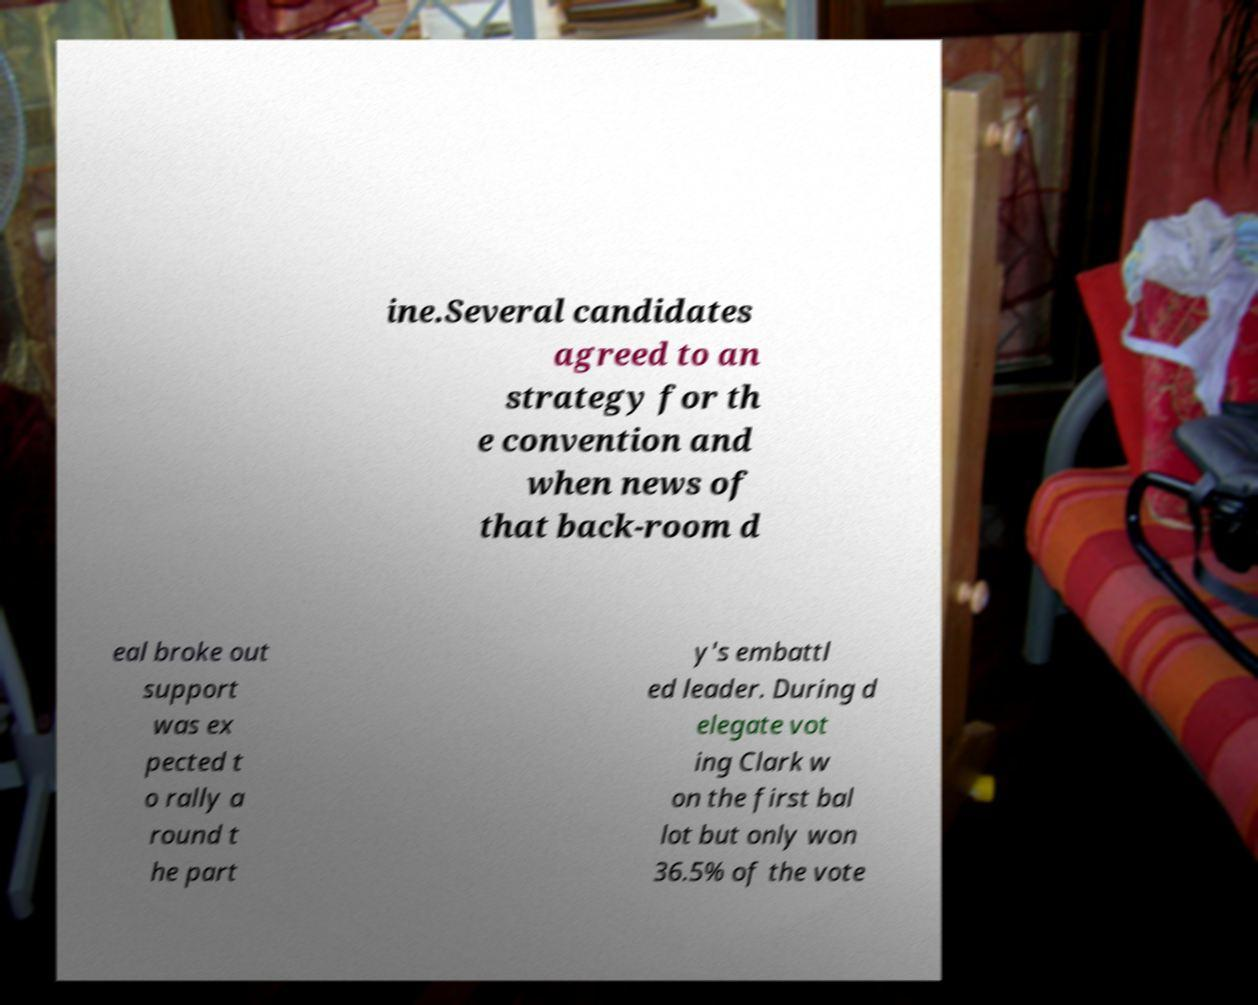I need the written content from this picture converted into text. Can you do that? ine.Several candidates agreed to an strategy for th e convention and when news of that back-room d eal broke out support was ex pected t o rally a round t he part y's embattl ed leader. During d elegate vot ing Clark w on the first bal lot but only won 36.5% of the vote 